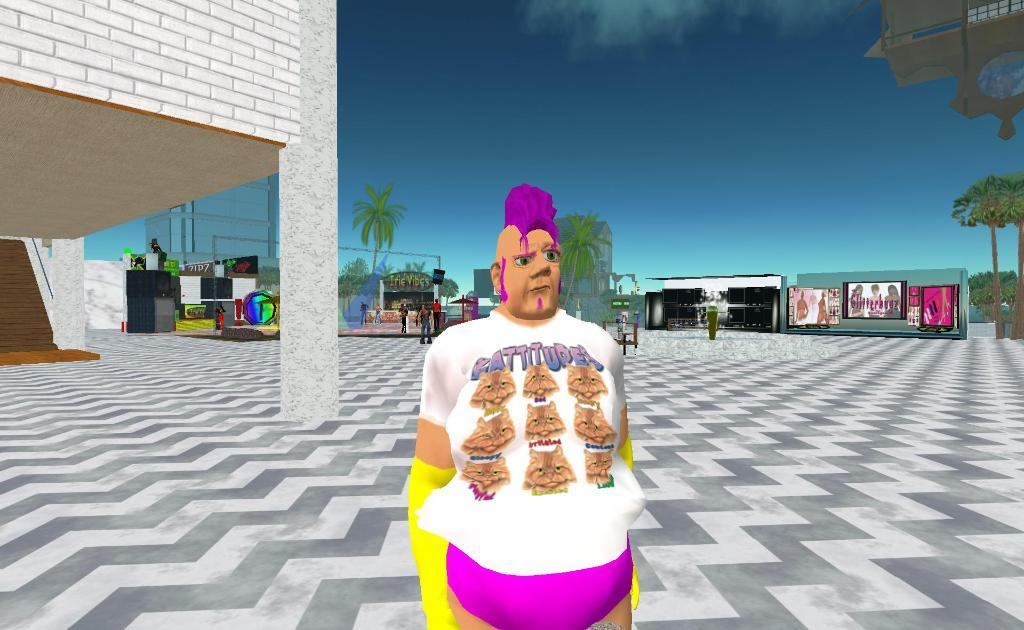How many people are present in the image? There are people in the image, but the exact number is not specified. What are the people wearing? The people in the image are wearing clothes. What type of structure can be seen in the image? There is a building in the image. What other objects or features can be seen in the image? There is a tree, a poster, and a footpath in the image. What is visible in the background of the image? The sky is visible in the image. What type of knife is being used by the person in the image? There is no knife present in the image. How high can the person jump in the image? There is no person jumping in the image. 